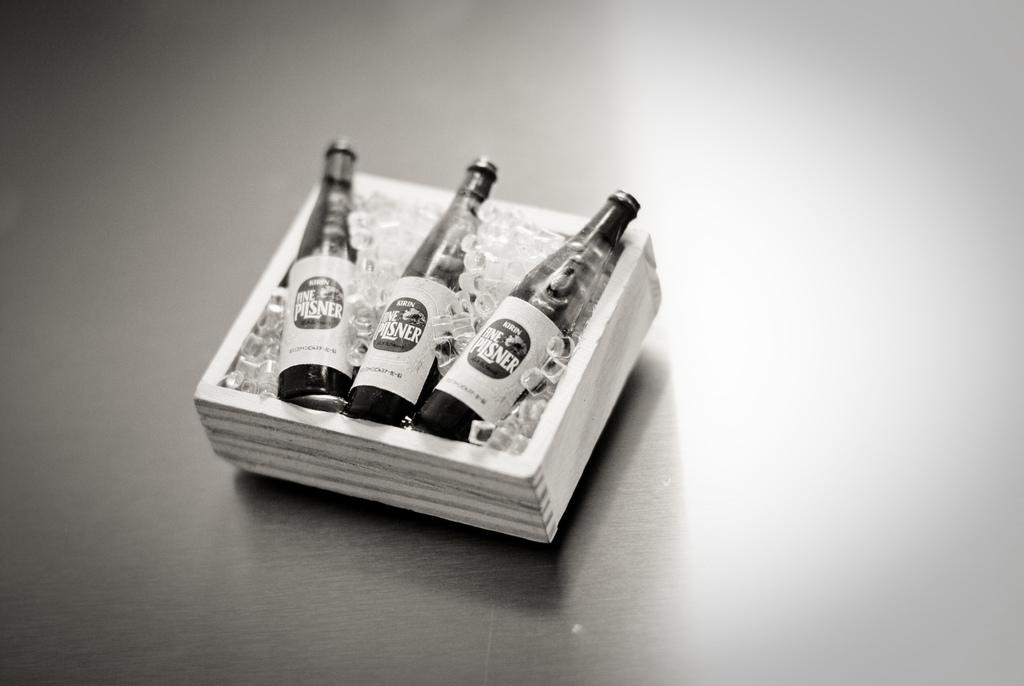What type of items can be seen in the image? There are beverage bottles in the image. How are the beverage bottles arranged or organized? The beverage bottles are placed in a container. What type of chalk is being used to draw on the rule in the image? There is no chalk or rule present in the image; it only features beverage bottles in a container. 